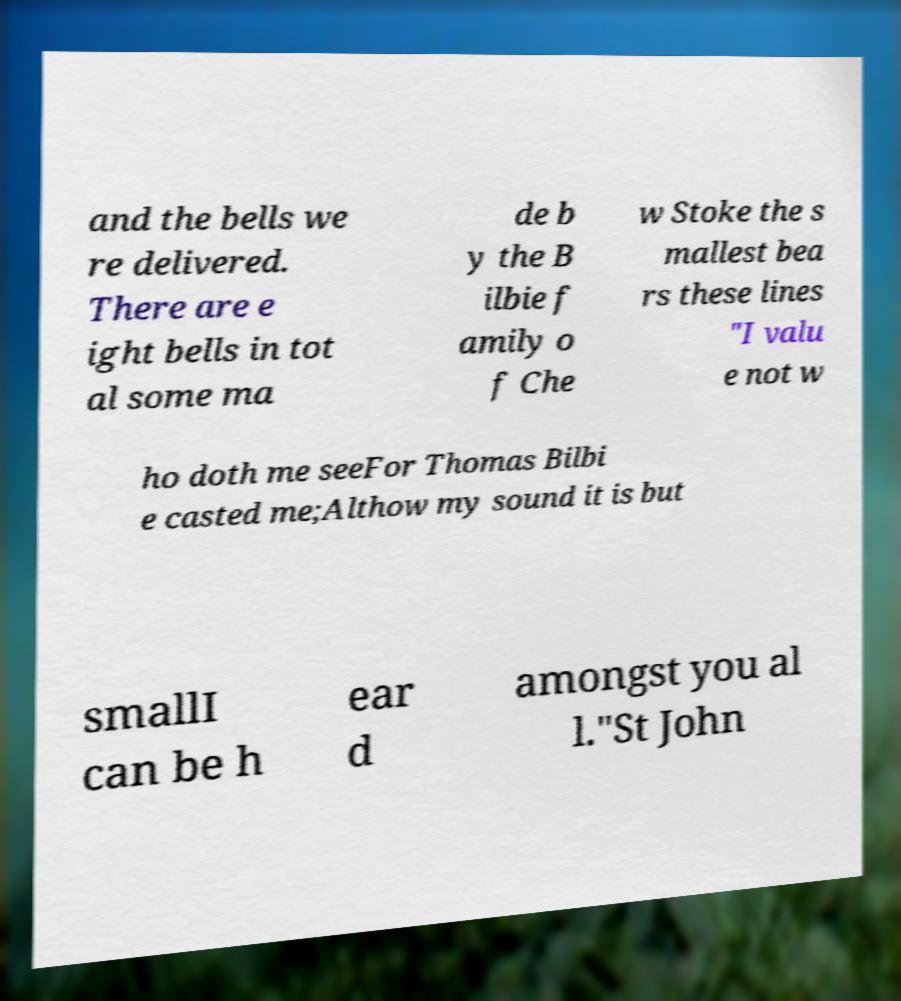Please identify and transcribe the text found in this image. and the bells we re delivered. There are e ight bells in tot al some ma de b y the B ilbie f amily o f Che w Stoke the s mallest bea rs these lines "I valu e not w ho doth me seeFor Thomas Bilbi e casted me;Althow my sound it is but smallI can be h ear d amongst you al l."St John 